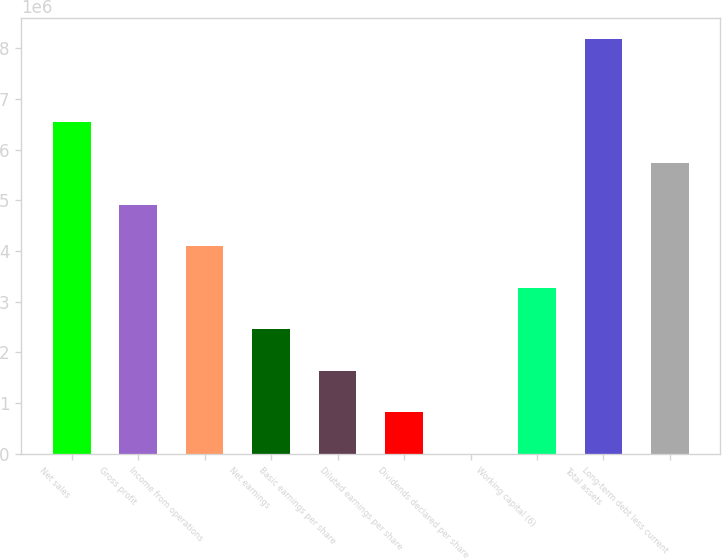<chart> <loc_0><loc_0><loc_500><loc_500><bar_chart><fcel>Net sales<fcel>Gross profit<fcel>Income from operations<fcel>Net earnings<fcel>Basic earnings per share<fcel>Diluted earnings per share<fcel>Dividends declared per share<fcel>Working capital (6)<fcel>Total assets<fcel>Long-term debt less current<nl><fcel>6.54798e+06<fcel>4.91099e+06<fcel>4.09249e+06<fcel>2.45549e+06<fcel>1.637e+06<fcel>818499<fcel>0.69<fcel>3.27399e+06<fcel>8.18498e+06<fcel>5.72949e+06<nl></chart> 